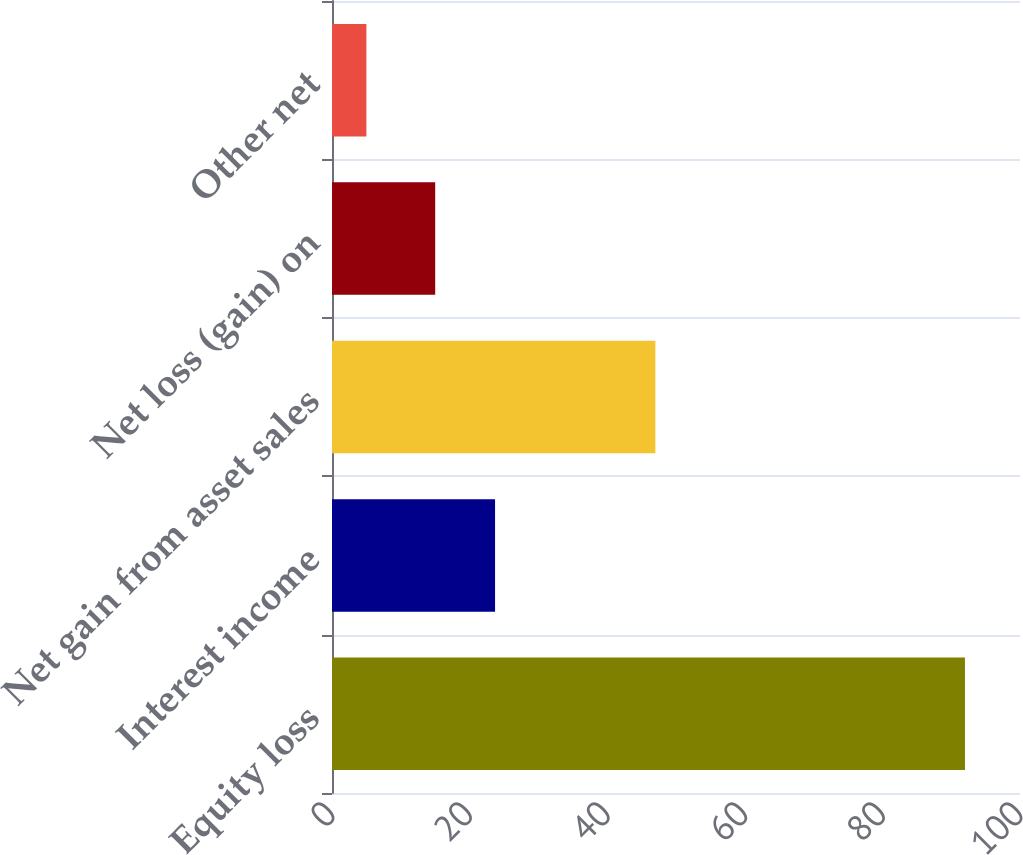<chart> <loc_0><loc_0><loc_500><loc_500><bar_chart><fcel>Equity loss<fcel>Interest income<fcel>Net gain from asset sales<fcel>Net loss (gain) on<fcel>Other net<nl><fcel>92<fcel>23.7<fcel>47<fcel>15<fcel>5<nl></chart> 